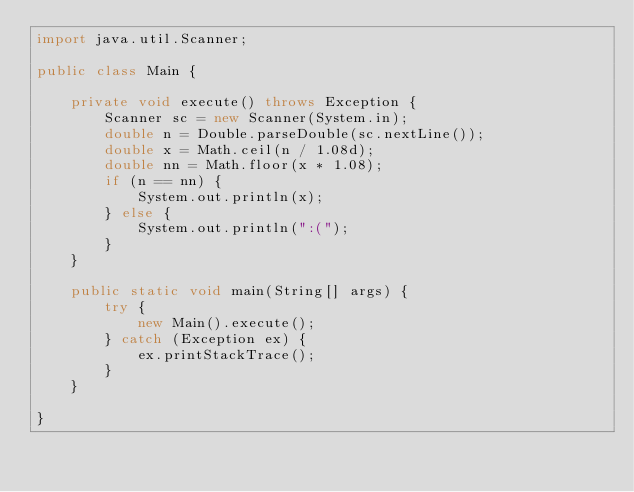Convert code to text. <code><loc_0><loc_0><loc_500><loc_500><_Java_>import java.util.Scanner;

public class Main {

    private void execute() throws Exception {
        Scanner sc = new Scanner(System.in);
        double n = Double.parseDouble(sc.nextLine());
        double x = Math.ceil(n / 1.08d);
        double nn = Math.floor(x * 1.08);
        if (n == nn) {
            System.out.println(x);
        } else {
            System.out.println(":(");
        }
    }

    public static void main(String[] args) {
        try {
            new Main().execute();
        } catch (Exception ex) {
            ex.printStackTrace();
        }
    }

}</code> 